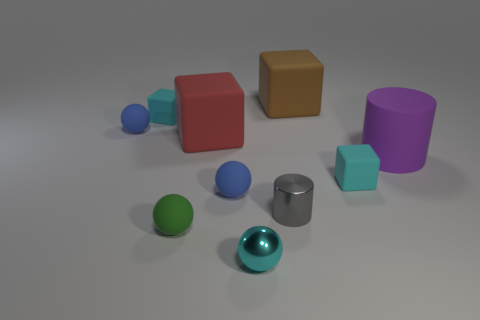What color is the tiny sphere behind the rubber cube to the right of the brown matte cube?
Provide a succinct answer. Blue. Is the number of large brown blocks on the left side of the brown matte cube less than the number of blocks in front of the rubber cylinder?
Your response must be concise. Yes. How many things are either cyan things that are to the left of the green matte thing or large cylinders?
Keep it short and to the point. 2. Does the cyan object left of the red thing have the same size as the cyan metallic ball?
Ensure brevity in your answer.  Yes. Is the number of gray cylinders that are on the left side of the green sphere less than the number of large cyan metal blocks?
Your response must be concise. No. What is the material of the green object that is the same size as the gray metallic thing?
Make the answer very short. Rubber. How many large things are purple cylinders or balls?
Provide a short and direct response. 1. How many objects are tiny blue rubber balls that are in front of the large red thing or blocks that are in front of the large rubber cylinder?
Provide a short and direct response. 2. Is the number of tiny cyan metallic objects less than the number of blue rubber spheres?
Make the answer very short. Yes. There is a cyan metallic thing that is the same size as the gray metallic thing; what shape is it?
Ensure brevity in your answer.  Sphere. 